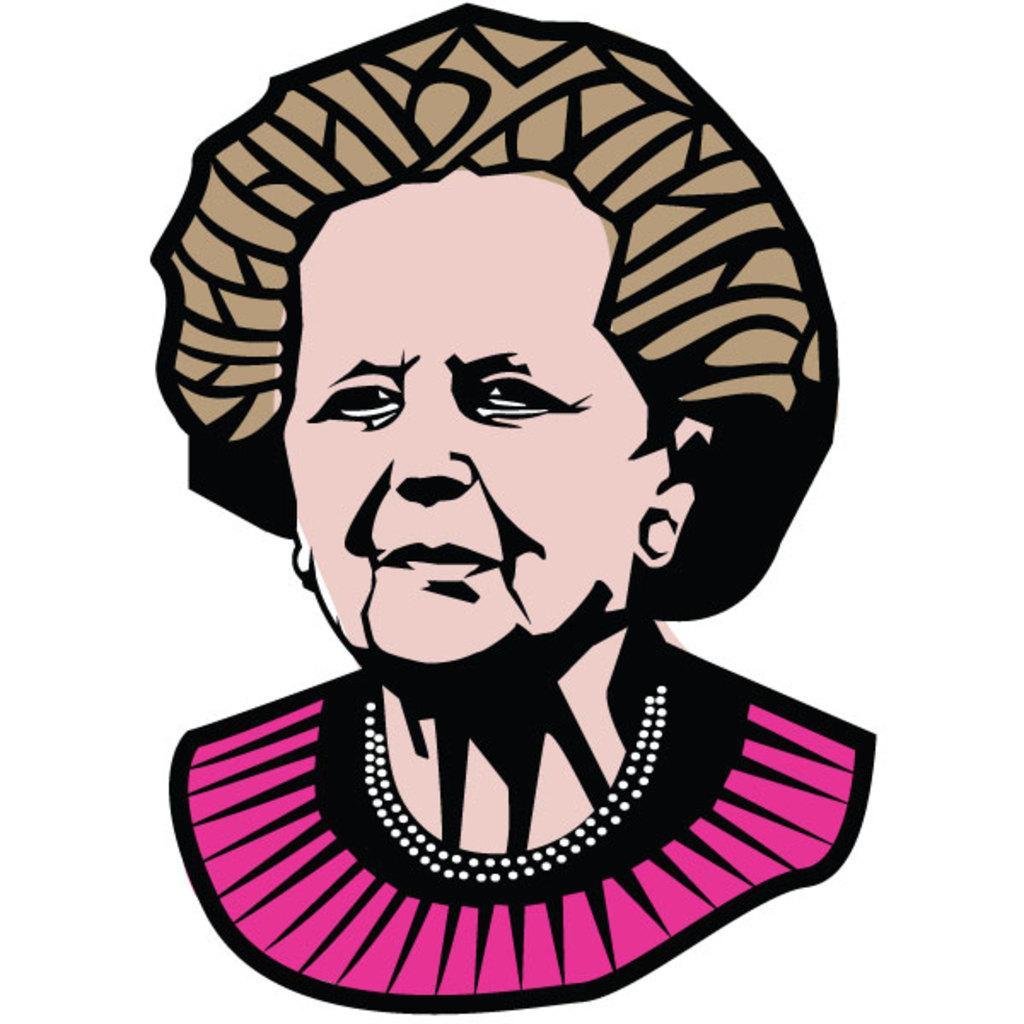Can you describe this image briefly? In this picture, we see the graphic art or an illustration of the woman who is wearing the pink and black dress. In the background, it is white in color. 